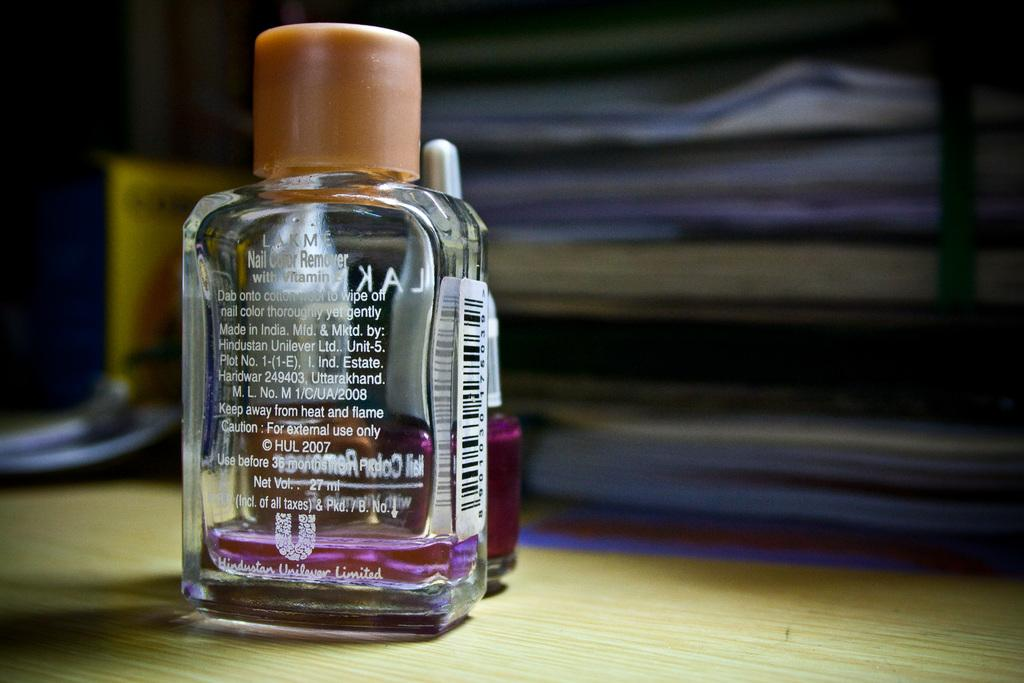<image>
Write a terse but informative summary of the picture. a clear bottle of Lakme Nail Color Remover on a table 